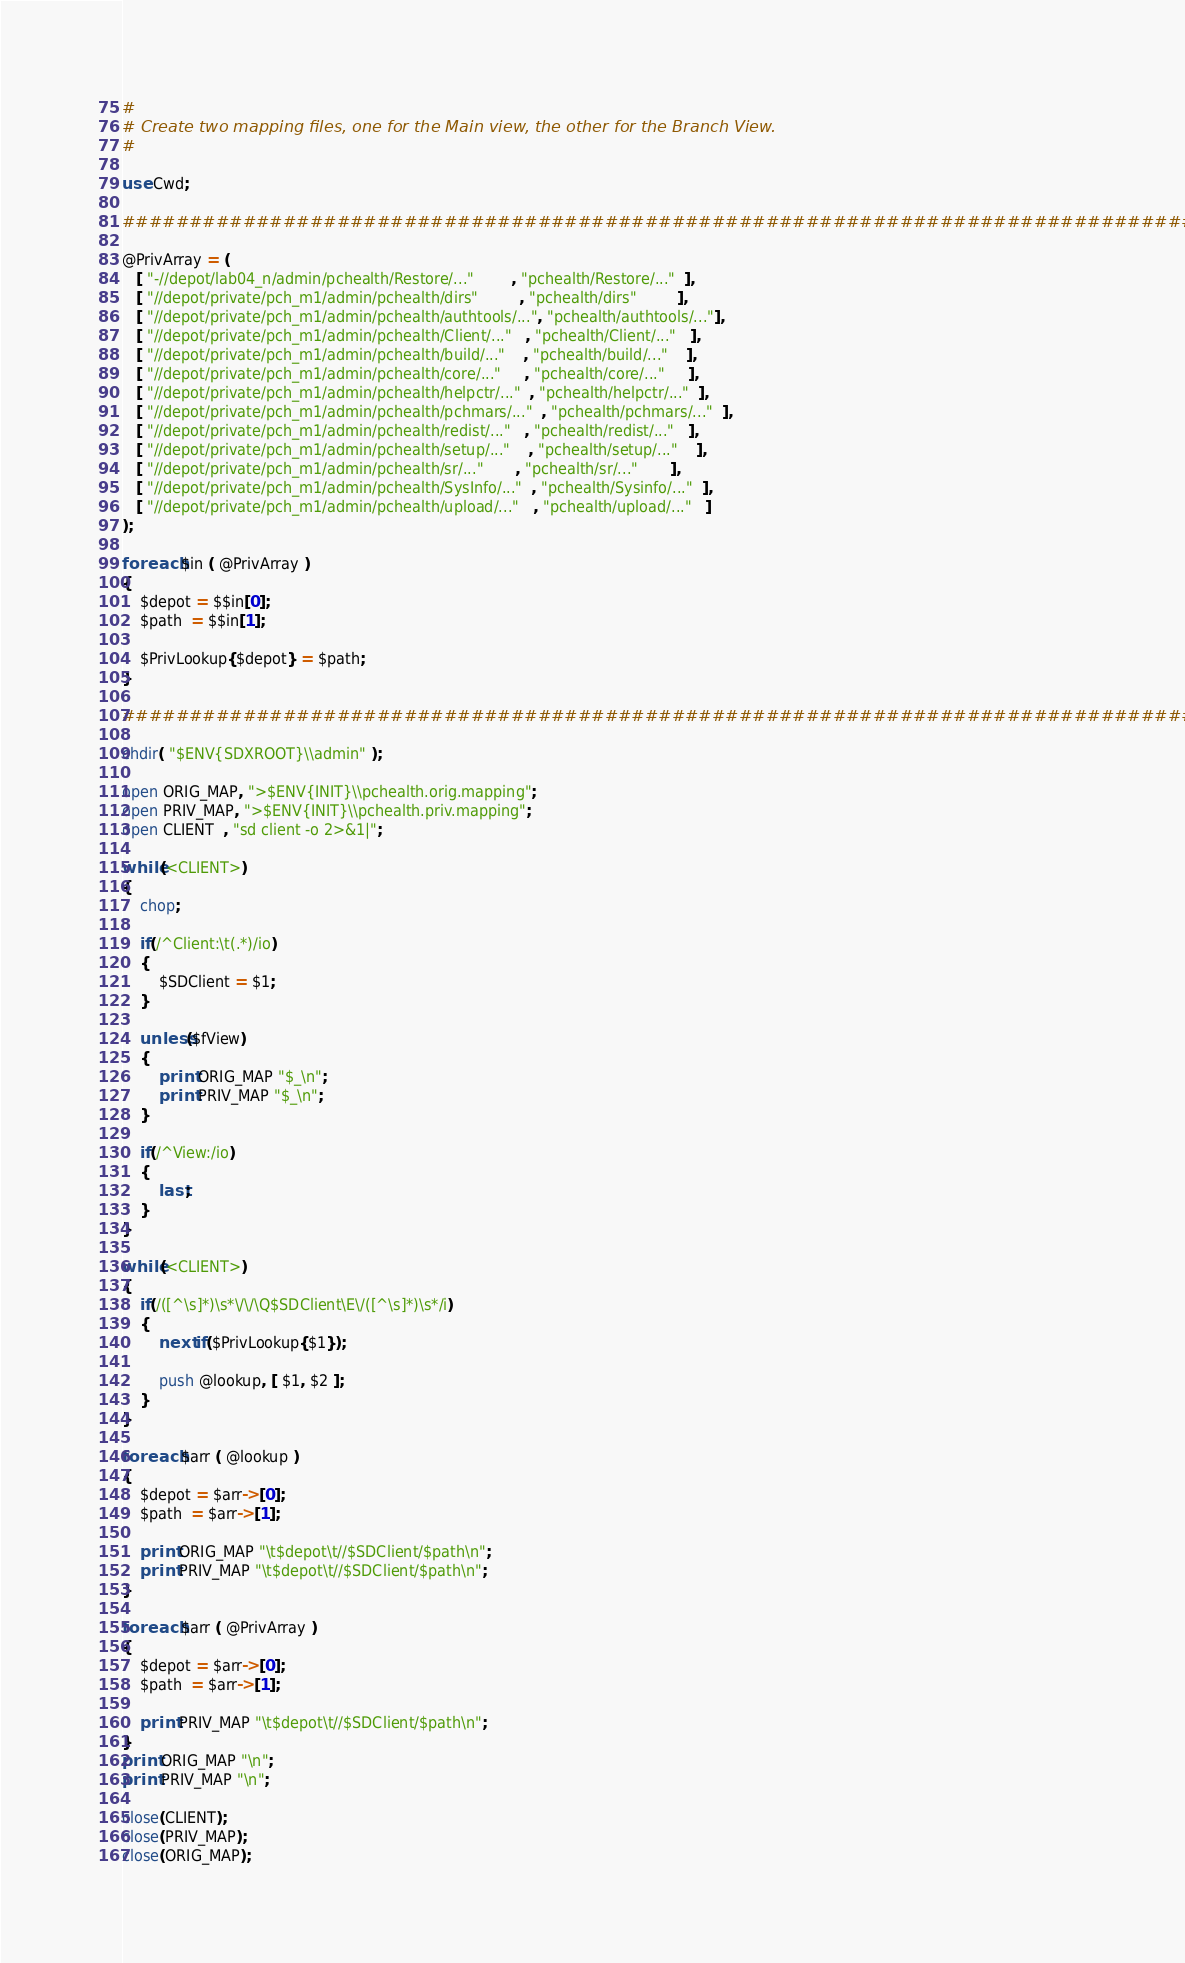Convert code to text. <code><loc_0><loc_0><loc_500><loc_500><_Perl_>#
# Create two mapping files, one for the Main view, the other for the Branch View.
#

use Cwd;

################################################################################

@PrivArray = (
   [ "-//depot/lab04_n/admin/pchealth/Restore/..."        , "pchealth/Restore/..."  ],
   [ "//depot/private/pch_m1/admin/pchealth/dirs"         , "pchealth/dirs"         ],
   [ "//depot/private/pch_m1/admin/pchealth/authtools/...", "pchealth/authtools/..."],
   [ "//depot/private/pch_m1/admin/pchealth/Client/..."   , "pchealth/Client/..."   ],
   [ "//depot/private/pch_m1/admin/pchealth/build/..."    , "pchealth/build/..."    ],
   [ "//depot/private/pch_m1/admin/pchealth/core/..."     , "pchealth/core/..."     ],
   [ "//depot/private/pch_m1/admin/pchealth/helpctr/..."  , "pchealth/helpctr/..."  ],
   [ "//depot/private/pch_m1/admin/pchealth/pchmars/..."  , "pchealth/pchmars/..."  ],
   [ "//depot/private/pch_m1/admin/pchealth/redist/..."   , "pchealth/redist/..."   ],
   [ "//depot/private/pch_m1/admin/pchealth/setup/..."    , "pchealth/setup/..."    ],
   [ "//depot/private/pch_m1/admin/pchealth/sr/..."       , "pchealth/sr/..."       ],
   [ "//depot/private/pch_m1/admin/pchealth/SysInfo/..."  , "pchealth/Sysinfo/..."  ],
   [ "//depot/private/pch_m1/admin/pchealth/upload/..."   , "pchealth/upload/..."   ]
);

foreach $in ( @PrivArray )
{
    $depot = $$in[0];
    $path  = $$in[1];

    $PrivLookup{$depot} = $path;
}

################################################################################

chdir( "$ENV{SDXROOT}\\admin" );

open ORIG_MAP, ">$ENV{INIT}\\pchealth.orig.mapping";
open PRIV_MAP, ">$ENV{INIT}\\pchealth.priv.mapping";
open CLIENT  , "sd client -o 2>&1|";

while(<CLIENT>)
{
    chop;

    if(/^Client:\t(.*)/io)
    {
        $SDClient = $1;
    }

    unless($fView)
    {
        print ORIG_MAP "$_\n";
        print PRIV_MAP "$_\n";
    }

    if(/^View:/io)
    {
        last;
    }
}

while(<CLIENT>)
{
    if(/([^\s]*)\s*\/\/\Q$SDClient\E\/([^\s]*)\s*/i)
    {
        next if($PrivLookup{$1});

        push @lookup, [ $1, $2 ];
    }
}

foreach $arr ( @lookup )
{
    $depot = $arr->[0];
    $path  = $arr->[1];

    print ORIG_MAP "\t$depot\t//$SDClient/$path\n";
    print PRIV_MAP "\t$depot\t//$SDClient/$path\n";
}

foreach $arr ( @PrivArray )
{
    $depot = $arr->[0];
    $path  = $arr->[1];

    print PRIV_MAP "\t$depot\t//$SDClient/$path\n";
}
print ORIG_MAP "\n";
print PRIV_MAP "\n";

close(CLIENT);
close(PRIV_MAP);
close(ORIG_MAP);
</code> 